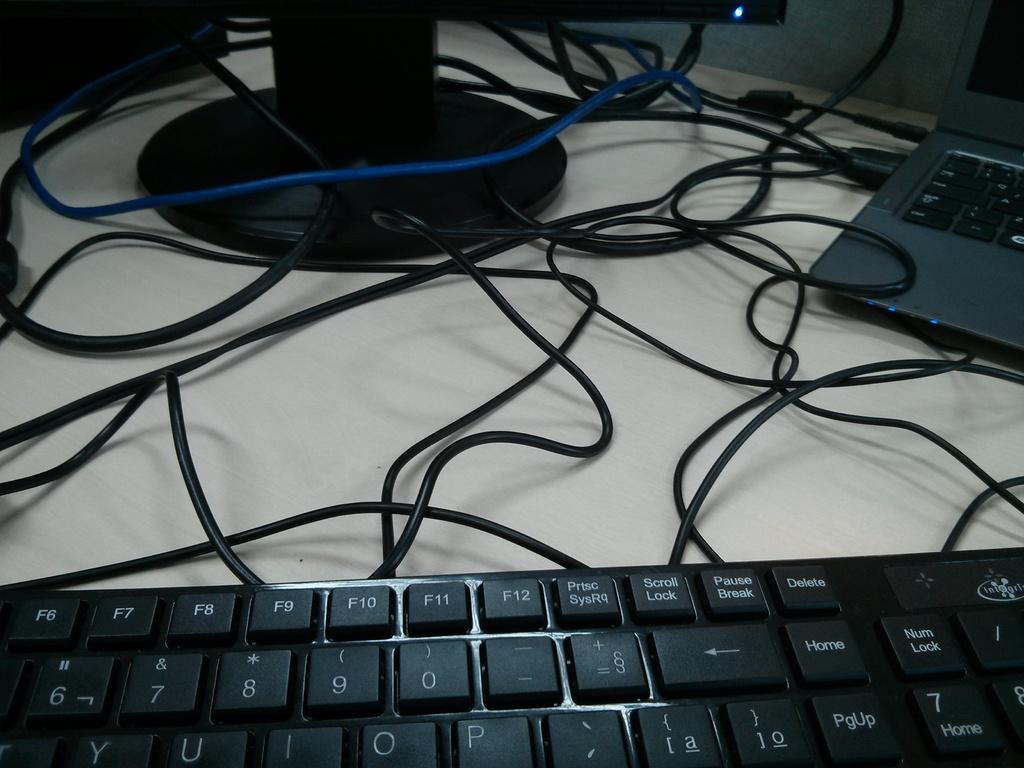What electronic device is present in the image? There is a keyboard and a laptop in the image. What might the keyboard and laptop be connected to? They are likely connected to a system, which is also present in the image. What can be seen in the image that might be used for connecting the devices? There are wires visible in the image. What type of furniture is present in the image? There is a table in the image. What is visible in the background of the image? There is a wall in the background of the image. What type of plantation is visible in the image? There is no plantation present in the image; it features electronic devices and a table. What nation is represented by the flag in the image? There is no flag visible in the image. 